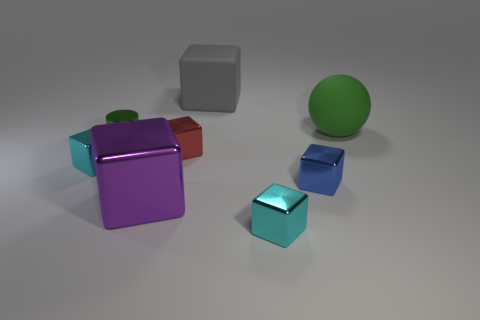Subtract all matte blocks. How many blocks are left? 5 Subtract all blue blocks. How many blocks are left? 5 Subtract all gray cubes. Subtract all blue cylinders. How many cubes are left? 5 Add 2 large green balls. How many objects exist? 10 Subtract all balls. How many objects are left? 7 Subtract 0 blue cylinders. How many objects are left? 8 Subtract all big red metallic cylinders. Subtract all shiny objects. How many objects are left? 2 Add 1 tiny cylinders. How many tiny cylinders are left? 2 Add 1 gray rubber objects. How many gray rubber objects exist? 2 